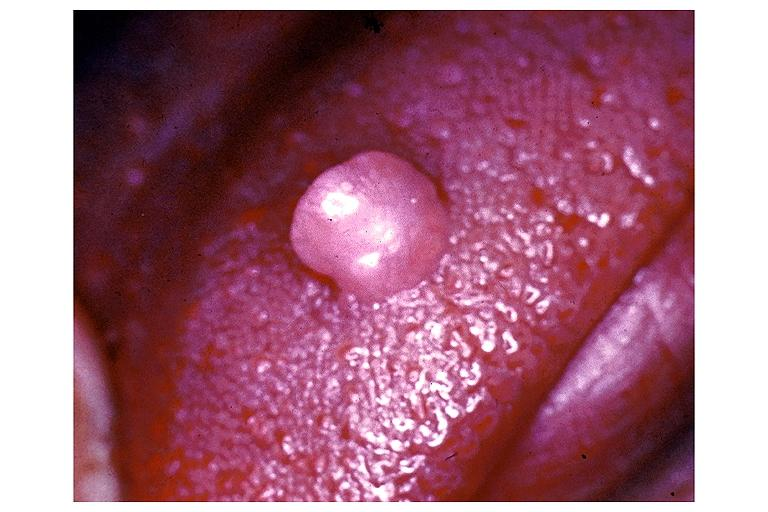s oral present?
Answer the question using a single word or phrase. Yes 